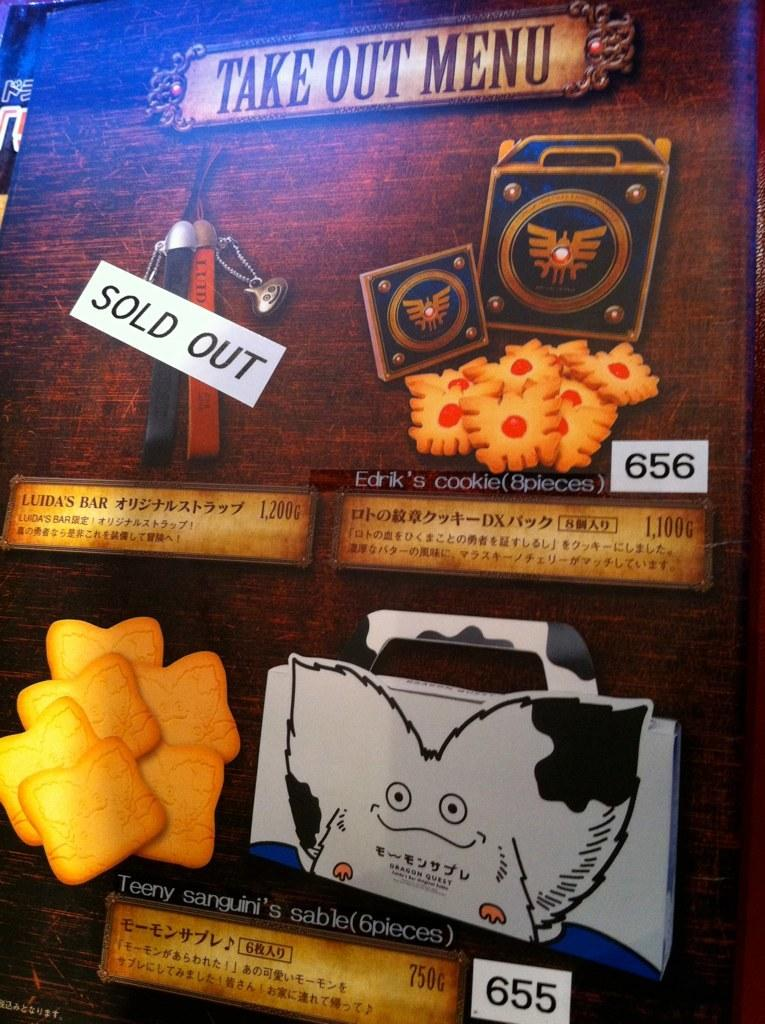What is the main object in the image? There is a text board in the image. Can you tell me how many firemen are standing next to the text board in the image? There is no fireman present in the image; it only features a text board. 